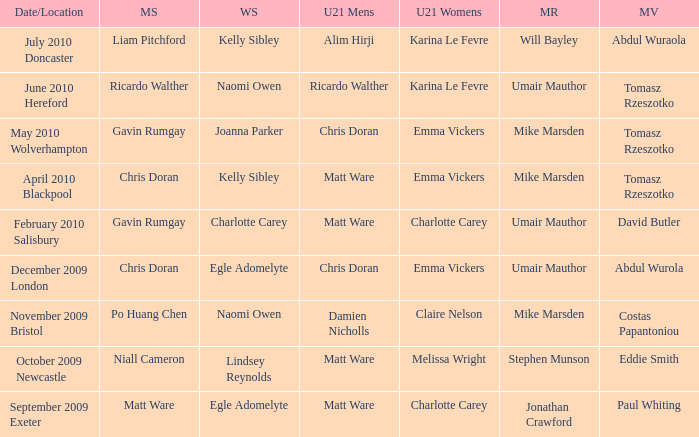Who won the mixed restricted when Tomasz Rzeszotko won the mixed veteran and Karina Le Fevre won the U21 womens? Umair Mauthor. 